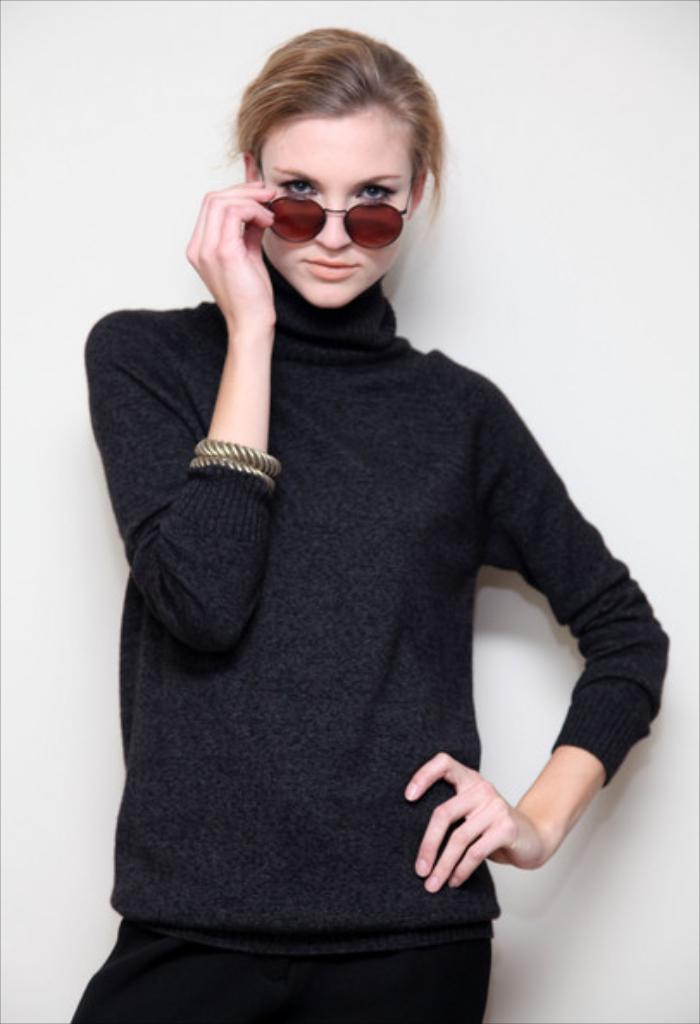Who is the main subject in the image? There is a woman in the image. What is the woman doing in the image? The woman is standing in the front. What is the woman wearing on her face? The woman is wearing brown shades. What is the woman wearing on her body? The woman is wearing a black dress. What accessories does the woman have on her wrists? The woman has two bracelets. What can be seen in the background of the image? There is a wall in the background of the image. What type of debt is the woman discussing in the image? There is no indication in the image that the woman is discussing debt or any financial matters. 